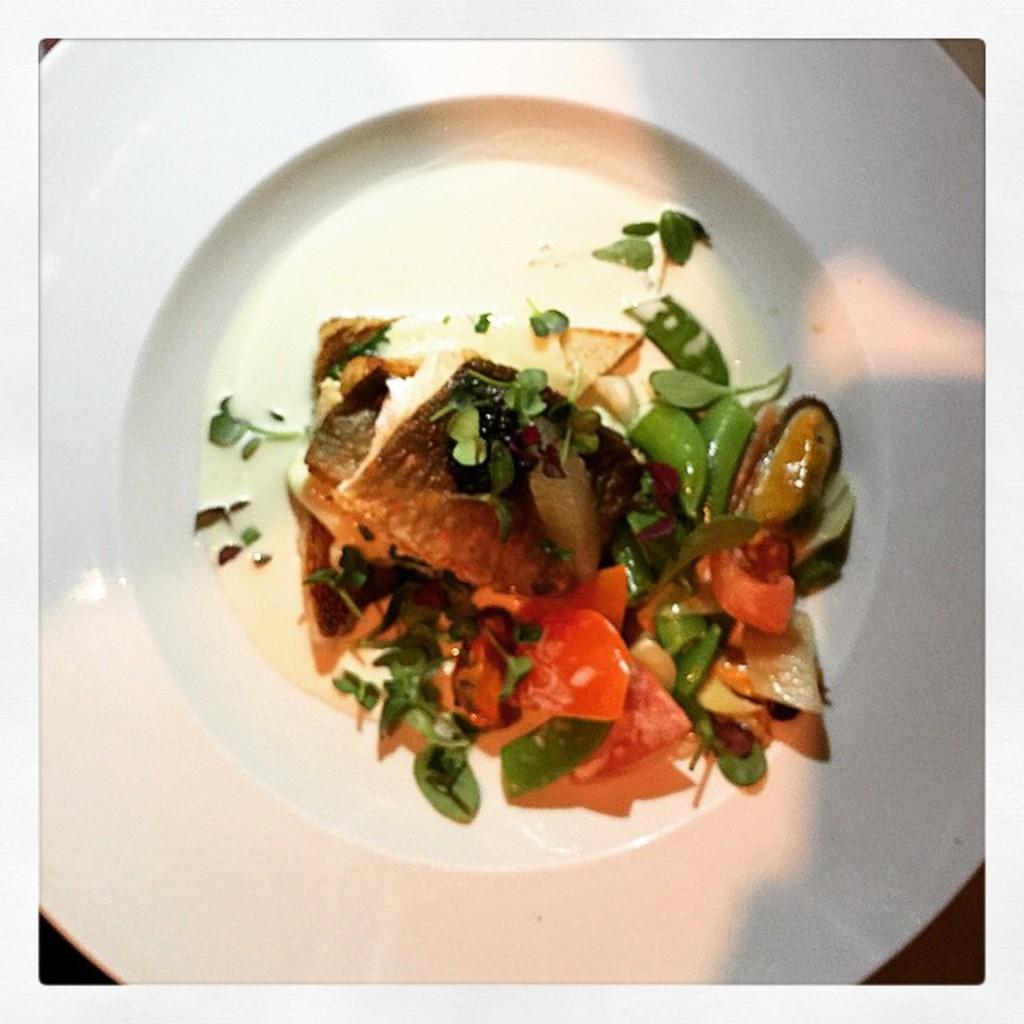Describe this image in one or two sentences. In this picture I can see food item on white color plate. 